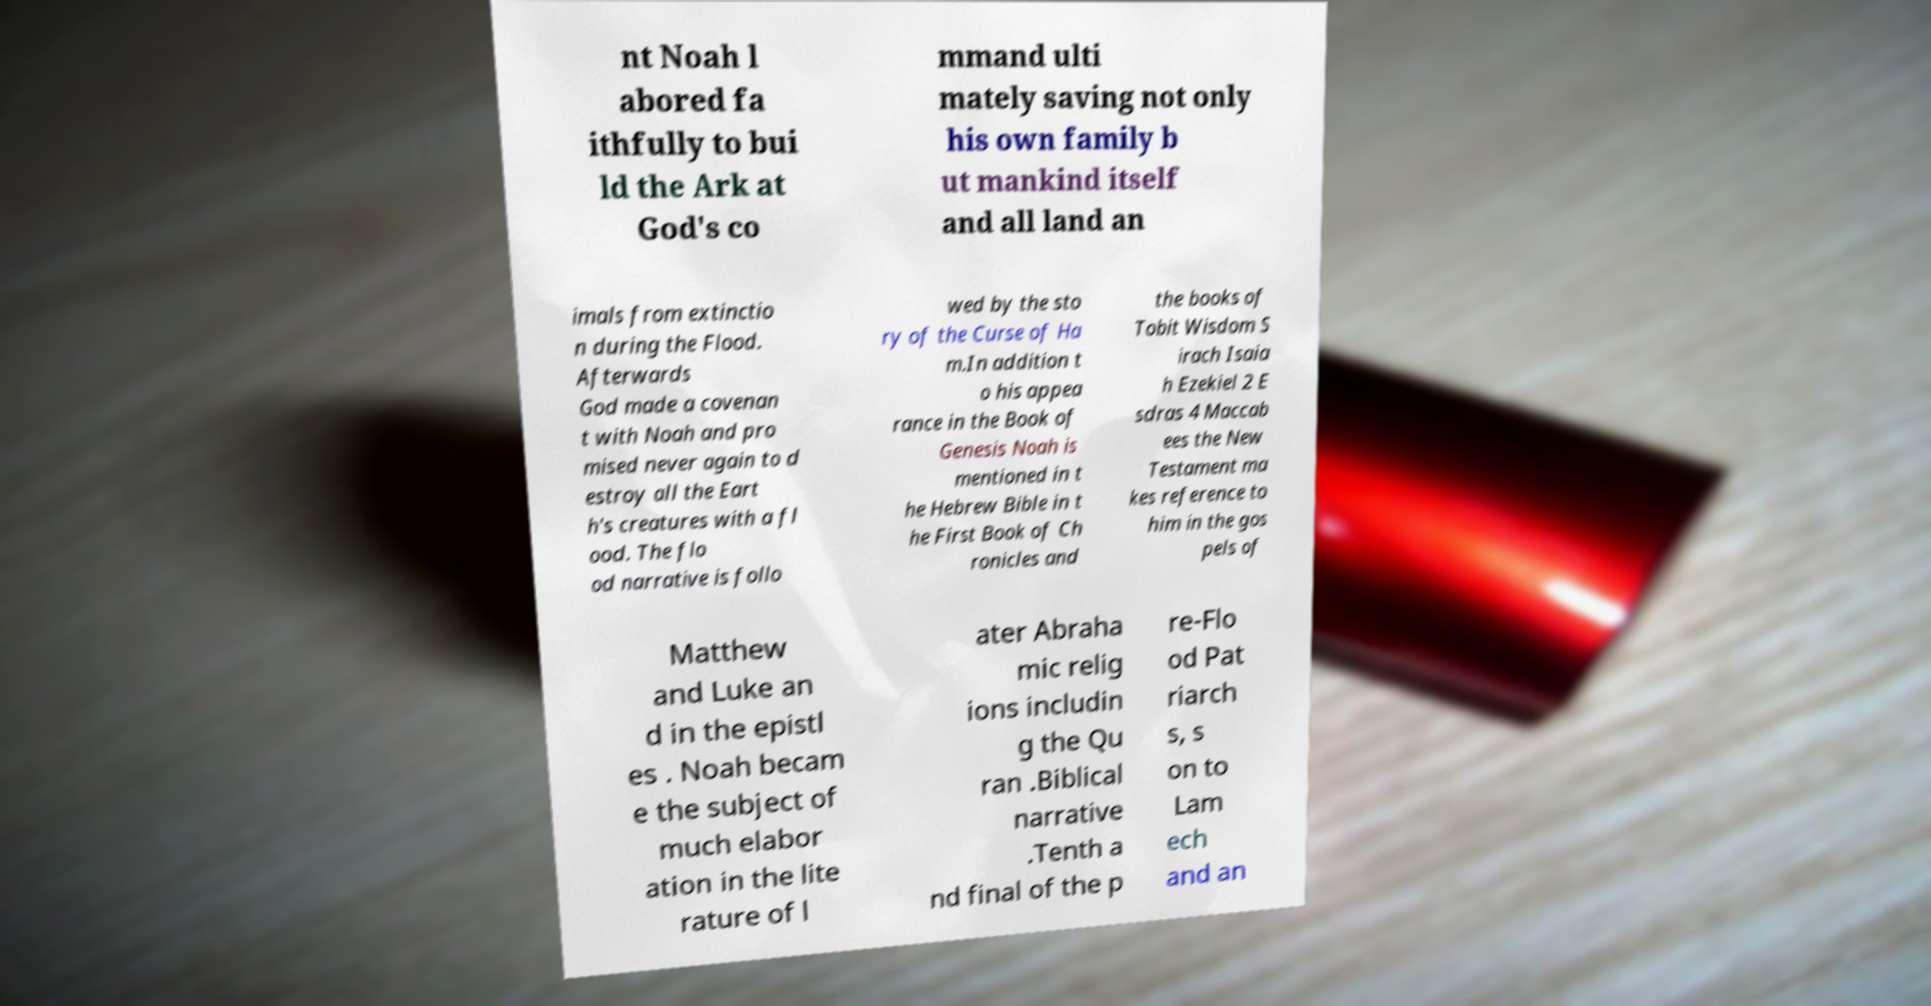What messages or text are displayed in this image? I need them in a readable, typed format. nt Noah l abored fa ithfully to bui ld the Ark at God's co mmand ulti mately saving not only his own family b ut mankind itself and all land an imals from extinctio n during the Flood. Afterwards God made a covenan t with Noah and pro mised never again to d estroy all the Eart h's creatures with a fl ood. The flo od narrative is follo wed by the sto ry of the Curse of Ha m.In addition t o his appea rance in the Book of Genesis Noah is mentioned in t he Hebrew Bible in t he First Book of Ch ronicles and the books of Tobit Wisdom S irach Isaia h Ezekiel 2 E sdras 4 Maccab ees the New Testament ma kes reference to him in the gos pels of Matthew and Luke an d in the epistl es . Noah becam e the subject of much elabor ation in the lite rature of l ater Abraha mic relig ions includin g the Qu ran .Biblical narrative .Tenth a nd final of the p re-Flo od Pat riarch s, s on to Lam ech and an 